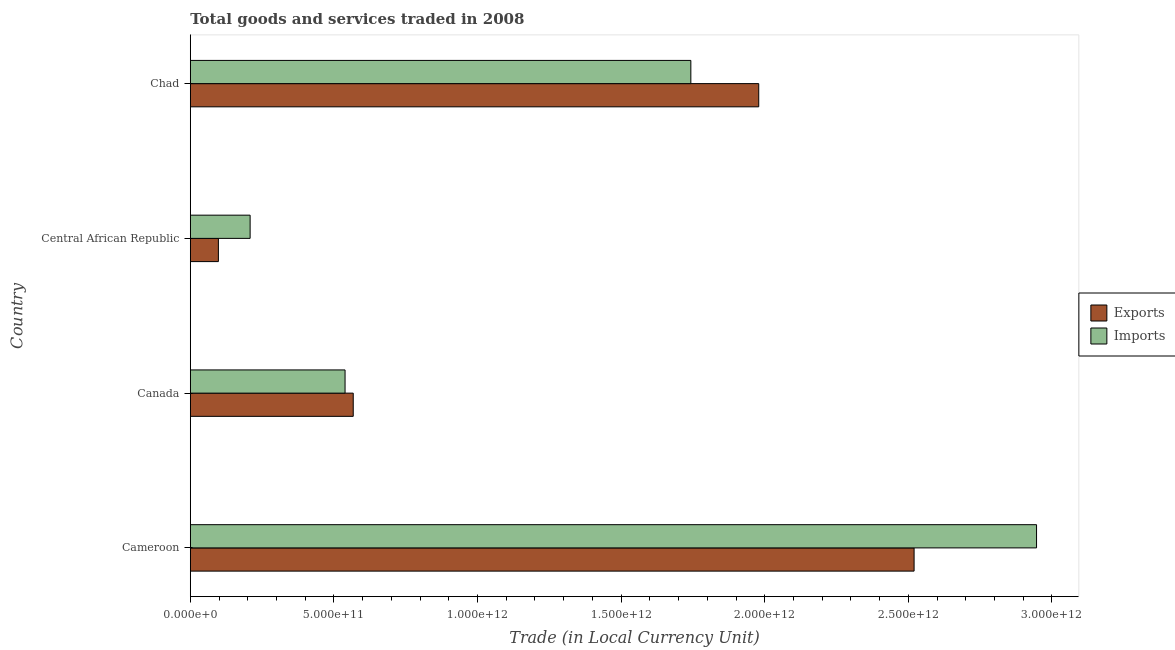Are the number of bars per tick equal to the number of legend labels?
Your answer should be compact. Yes. Are the number of bars on each tick of the Y-axis equal?
Your answer should be very brief. Yes. How many bars are there on the 4th tick from the top?
Offer a very short reply. 2. What is the label of the 4th group of bars from the top?
Make the answer very short. Cameroon. In how many cases, is the number of bars for a given country not equal to the number of legend labels?
Provide a succinct answer. 0. What is the imports of goods and services in Chad?
Offer a terse response. 1.74e+12. Across all countries, what is the maximum export of goods and services?
Provide a succinct answer. 2.52e+12. Across all countries, what is the minimum imports of goods and services?
Your answer should be compact. 2.08e+11. In which country was the imports of goods and services maximum?
Provide a short and direct response. Cameroon. In which country was the imports of goods and services minimum?
Offer a terse response. Central African Republic. What is the total imports of goods and services in the graph?
Your response must be concise. 5.44e+12. What is the difference between the export of goods and services in Cameroon and that in Central African Republic?
Your answer should be very brief. 2.42e+12. What is the difference between the imports of goods and services in Central African Republic and the export of goods and services in Chad?
Offer a terse response. -1.77e+12. What is the average imports of goods and services per country?
Your answer should be very brief. 1.36e+12. What is the difference between the imports of goods and services and export of goods and services in Chad?
Keep it short and to the point. -2.36e+11. In how many countries, is the export of goods and services greater than 2600000000000 LCU?
Your answer should be compact. 0. What is the ratio of the imports of goods and services in Cameroon to that in Canada?
Keep it short and to the point. 5.47. Is the export of goods and services in Canada less than that in Chad?
Provide a succinct answer. Yes. What is the difference between the highest and the second highest export of goods and services?
Keep it short and to the point. 5.41e+11. What is the difference between the highest and the lowest imports of goods and services?
Make the answer very short. 2.74e+12. Is the sum of the imports of goods and services in Central African Republic and Chad greater than the maximum export of goods and services across all countries?
Ensure brevity in your answer.  No. What does the 1st bar from the top in Central African Republic represents?
Offer a very short reply. Imports. What does the 2nd bar from the bottom in Central African Republic represents?
Make the answer very short. Imports. Are all the bars in the graph horizontal?
Offer a terse response. Yes. How many countries are there in the graph?
Your response must be concise. 4. What is the difference between two consecutive major ticks on the X-axis?
Provide a succinct answer. 5.00e+11. How are the legend labels stacked?
Your answer should be compact. Vertical. What is the title of the graph?
Give a very brief answer. Total goods and services traded in 2008. Does "Number of arrivals" appear as one of the legend labels in the graph?
Give a very brief answer. No. What is the label or title of the X-axis?
Your response must be concise. Trade (in Local Currency Unit). What is the label or title of the Y-axis?
Provide a short and direct response. Country. What is the Trade (in Local Currency Unit) in Exports in Cameroon?
Provide a succinct answer. 2.52e+12. What is the Trade (in Local Currency Unit) in Imports in Cameroon?
Give a very brief answer. 2.95e+12. What is the Trade (in Local Currency Unit) of Exports in Canada?
Provide a short and direct response. 5.67e+11. What is the Trade (in Local Currency Unit) in Imports in Canada?
Offer a very short reply. 5.39e+11. What is the Trade (in Local Currency Unit) in Exports in Central African Republic?
Offer a very short reply. 9.78e+1. What is the Trade (in Local Currency Unit) in Imports in Central African Republic?
Your answer should be very brief. 2.08e+11. What is the Trade (in Local Currency Unit) in Exports in Chad?
Your response must be concise. 1.98e+12. What is the Trade (in Local Currency Unit) in Imports in Chad?
Offer a very short reply. 1.74e+12. Across all countries, what is the maximum Trade (in Local Currency Unit) in Exports?
Your answer should be compact. 2.52e+12. Across all countries, what is the maximum Trade (in Local Currency Unit) of Imports?
Offer a terse response. 2.95e+12. Across all countries, what is the minimum Trade (in Local Currency Unit) of Exports?
Make the answer very short. 9.78e+1. Across all countries, what is the minimum Trade (in Local Currency Unit) of Imports?
Make the answer very short. 2.08e+11. What is the total Trade (in Local Currency Unit) of Exports in the graph?
Make the answer very short. 5.16e+12. What is the total Trade (in Local Currency Unit) of Imports in the graph?
Your answer should be compact. 5.44e+12. What is the difference between the Trade (in Local Currency Unit) in Exports in Cameroon and that in Canada?
Your answer should be very brief. 1.95e+12. What is the difference between the Trade (in Local Currency Unit) in Imports in Cameroon and that in Canada?
Provide a short and direct response. 2.41e+12. What is the difference between the Trade (in Local Currency Unit) of Exports in Cameroon and that in Central African Republic?
Your answer should be very brief. 2.42e+12. What is the difference between the Trade (in Local Currency Unit) of Imports in Cameroon and that in Central African Republic?
Provide a succinct answer. 2.74e+12. What is the difference between the Trade (in Local Currency Unit) of Exports in Cameroon and that in Chad?
Provide a succinct answer. 5.41e+11. What is the difference between the Trade (in Local Currency Unit) in Imports in Cameroon and that in Chad?
Make the answer very short. 1.20e+12. What is the difference between the Trade (in Local Currency Unit) in Exports in Canada and that in Central African Republic?
Offer a terse response. 4.70e+11. What is the difference between the Trade (in Local Currency Unit) of Imports in Canada and that in Central African Republic?
Your response must be concise. 3.31e+11. What is the difference between the Trade (in Local Currency Unit) in Exports in Canada and that in Chad?
Your response must be concise. -1.41e+12. What is the difference between the Trade (in Local Currency Unit) of Imports in Canada and that in Chad?
Provide a succinct answer. -1.20e+12. What is the difference between the Trade (in Local Currency Unit) in Exports in Central African Republic and that in Chad?
Offer a terse response. -1.88e+12. What is the difference between the Trade (in Local Currency Unit) of Imports in Central African Republic and that in Chad?
Keep it short and to the point. -1.53e+12. What is the difference between the Trade (in Local Currency Unit) of Exports in Cameroon and the Trade (in Local Currency Unit) of Imports in Canada?
Make the answer very short. 1.98e+12. What is the difference between the Trade (in Local Currency Unit) in Exports in Cameroon and the Trade (in Local Currency Unit) in Imports in Central African Republic?
Provide a short and direct response. 2.31e+12. What is the difference between the Trade (in Local Currency Unit) in Exports in Cameroon and the Trade (in Local Currency Unit) in Imports in Chad?
Offer a terse response. 7.77e+11. What is the difference between the Trade (in Local Currency Unit) in Exports in Canada and the Trade (in Local Currency Unit) in Imports in Central African Republic?
Keep it short and to the point. 3.59e+11. What is the difference between the Trade (in Local Currency Unit) of Exports in Canada and the Trade (in Local Currency Unit) of Imports in Chad?
Your answer should be very brief. -1.18e+12. What is the difference between the Trade (in Local Currency Unit) in Exports in Central African Republic and the Trade (in Local Currency Unit) in Imports in Chad?
Offer a terse response. -1.64e+12. What is the average Trade (in Local Currency Unit) in Exports per country?
Ensure brevity in your answer.  1.29e+12. What is the average Trade (in Local Currency Unit) in Imports per country?
Keep it short and to the point. 1.36e+12. What is the difference between the Trade (in Local Currency Unit) in Exports and Trade (in Local Currency Unit) in Imports in Cameroon?
Give a very brief answer. -4.26e+11. What is the difference between the Trade (in Local Currency Unit) of Exports and Trade (in Local Currency Unit) of Imports in Canada?
Provide a short and direct response. 2.85e+1. What is the difference between the Trade (in Local Currency Unit) in Exports and Trade (in Local Currency Unit) in Imports in Central African Republic?
Give a very brief answer. -1.11e+11. What is the difference between the Trade (in Local Currency Unit) of Exports and Trade (in Local Currency Unit) of Imports in Chad?
Offer a terse response. 2.36e+11. What is the ratio of the Trade (in Local Currency Unit) in Exports in Cameroon to that in Canada?
Your answer should be very brief. 4.44. What is the ratio of the Trade (in Local Currency Unit) in Imports in Cameroon to that in Canada?
Your answer should be compact. 5.47. What is the ratio of the Trade (in Local Currency Unit) in Exports in Cameroon to that in Central African Republic?
Ensure brevity in your answer.  25.76. What is the ratio of the Trade (in Local Currency Unit) in Imports in Cameroon to that in Central African Republic?
Provide a succinct answer. 14.14. What is the ratio of the Trade (in Local Currency Unit) of Exports in Cameroon to that in Chad?
Your response must be concise. 1.27. What is the ratio of the Trade (in Local Currency Unit) in Imports in Cameroon to that in Chad?
Your answer should be compact. 1.69. What is the ratio of the Trade (in Local Currency Unit) of Exports in Canada to that in Central African Republic?
Your answer should be compact. 5.8. What is the ratio of the Trade (in Local Currency Unit) in Imports in Canada to that in Central African Republic?
Your answer should be very brief. 2.59. What is the ratio of the Trade (in Local Currency Unit) of Exports in Canada to that in Chad?
Offer a terse response. 0.29. What is the ratio of the Trade (in Local Currency Unit) of Imports in Canada to that in Chad?
Give a very brief answer. 0.31. What is the ratio of the Trade (in Local Currency Unit) of Exports in Central African Republic to that in Chad?
Make the answer very short. 0.05. What is the ratio of the Trade (in Local Currency Unit) in Imports in Central African Republic to that in Chad?
Your answer should be compact. 0.12. What is the difference between the highest and the second highest Trade (in Local Currency Unit) of Exports?
Your answer should be very brief. 5.41e+11. What is the difference between the highest and the second highest Trade (in Local Currency Unit) in Imports?
Provide a succinct answer. 1.20e+12. What is the difference between the highest and the lowest Trade (in Local Currency Unit) in Exports?
Provide a short and direct response. 2.42e+12. What is the difference between the highest and the lowest Trade (in Local Currency Unit) of Imports?
Offer a terse response. 2.74e+12. 